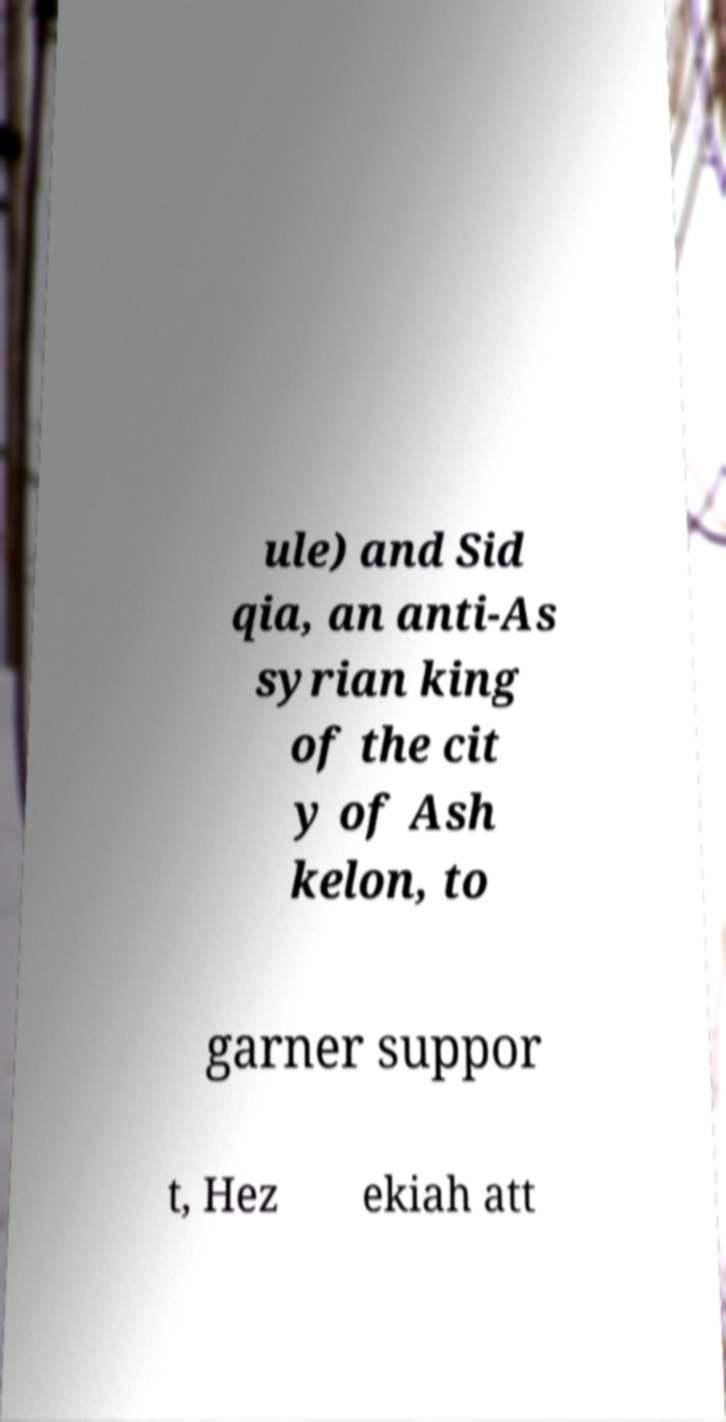Can you read and provide the text displayed in the image?This photo seems to have some interesting text. Can you extract and type it out for me? ule) and Sid qia, an anti-As syrian king of the cit y of Ash kelon, to garner suppor t, Hez ekiah att 